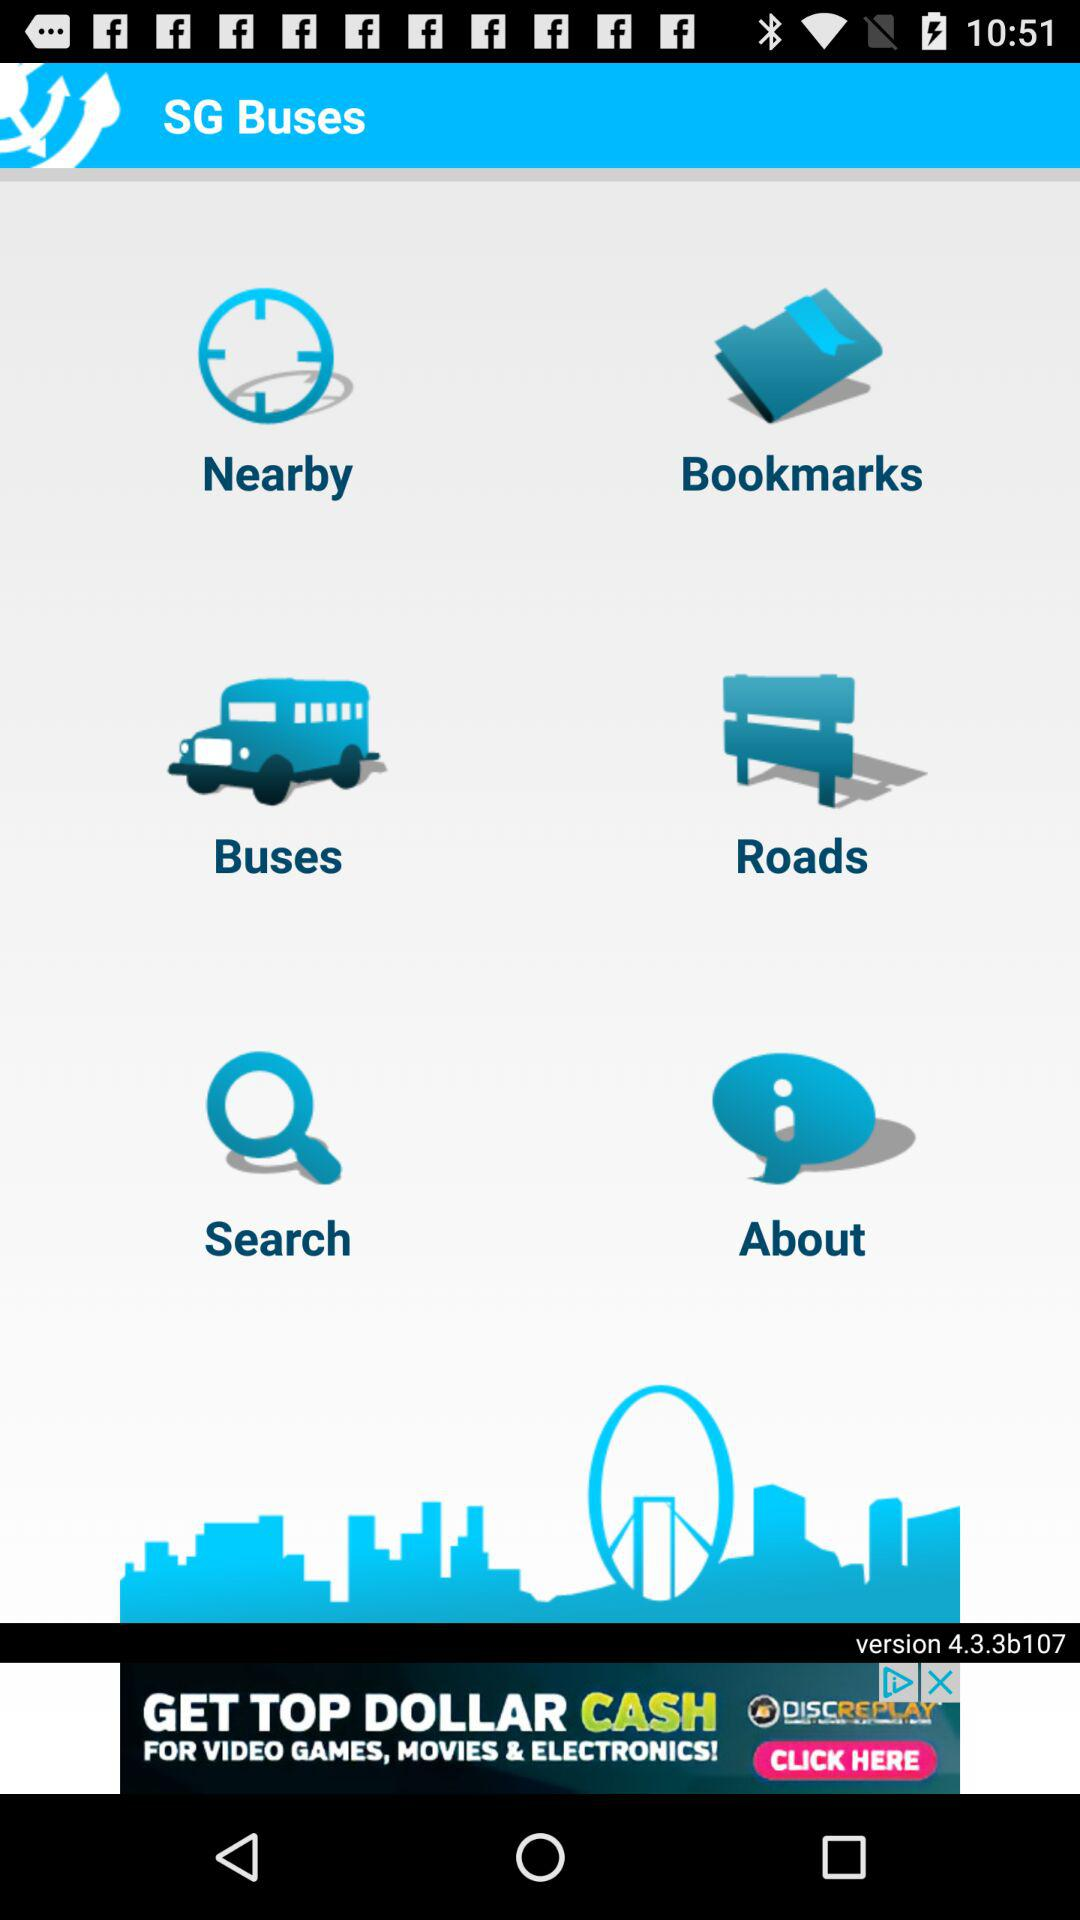What is the application name? The application name is "SG Buses". 